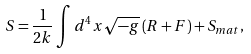Convert formula to latex. <formula><loc_0><loc_0><loc_500><loc_500>S = \frac { 1 } { 2 k } \int d ^ { 4 } x \sqrt { - g } \left ( R + F \right ) + S _ { m a t } ,</formula> 